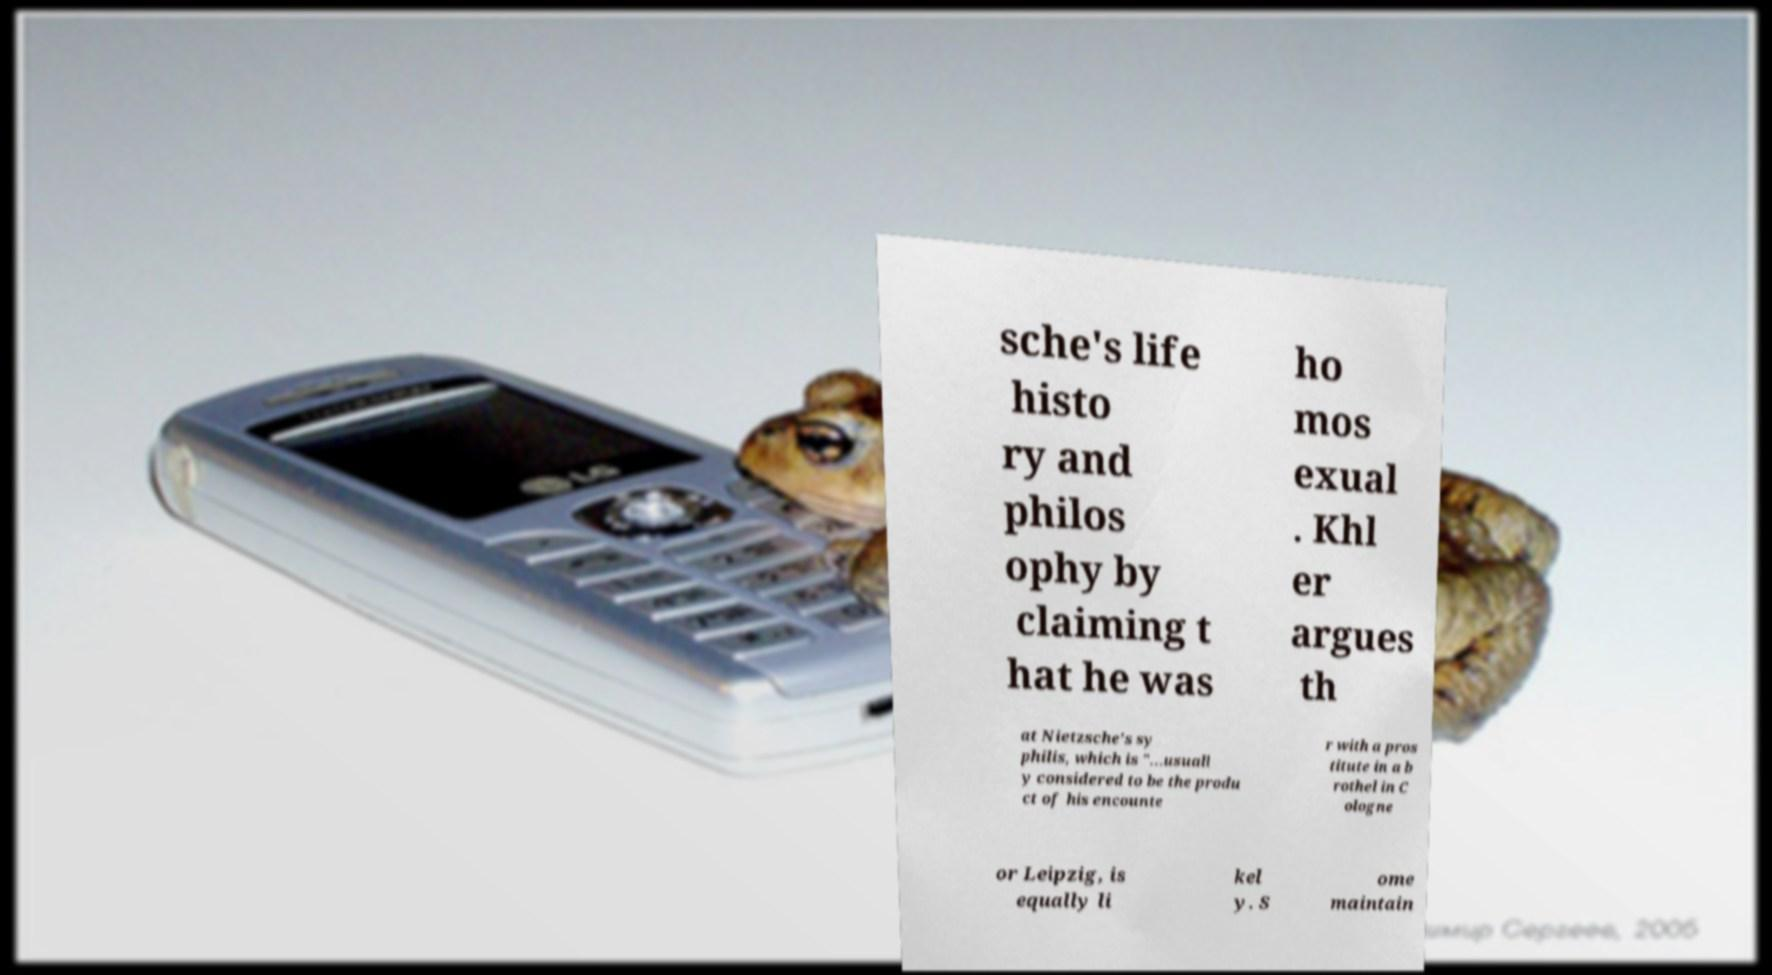Please identify and transcribe the text found in this image. sche's life histo ry and philos ophy by claiming t hat he was ho mos exual . Khl er argues th at Nietzsche's sy philis, which is "...usuall y considered to be the produ ct of his encounte r with a pros titute in a b rothel in C ologne or Leipzig, is equally li kel y. S ome maintain 